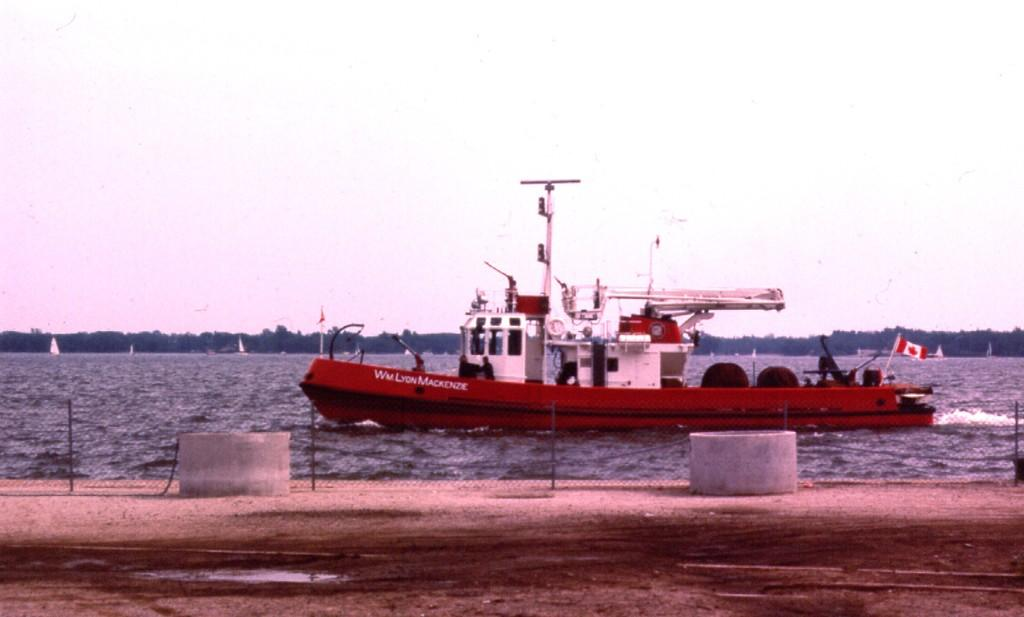What objects are present in the image that resemble storage units? There are containers in the image. What type of barrier can be seen in the image? There is a fence in the image. What is the boat's position in relation to the water in the image? The boat is above the water in the image. What type of decorative or symbolic objects are present in the image? There are flags in the image. What type of fabric is visible in the image? There are sails in the image, which are made of fabric. What type of natural scenery is visible in the background of the image? There are trees and a sky in the background of the image. How many people are involved in the fight depicted in the image? There is no fight depicted in the image; it features containers, a fence, a boat, flags, sails, trees, and a sky. What type of wool is used to make the sails in the image? There is no wool used to make the sails in the image; they are made of fabric. 